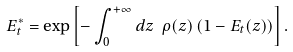Convert formula to latex. <formula><loc_0><loc_0><loc_500><loc_500>E ^ { * } _ { t } = \exp \left [ - \int _ { 0 } ^ { + \infty } d z \ \rho ( z ) \left ( 1 - E _ { t } ( z ) \right ) \right ] .</formula> 